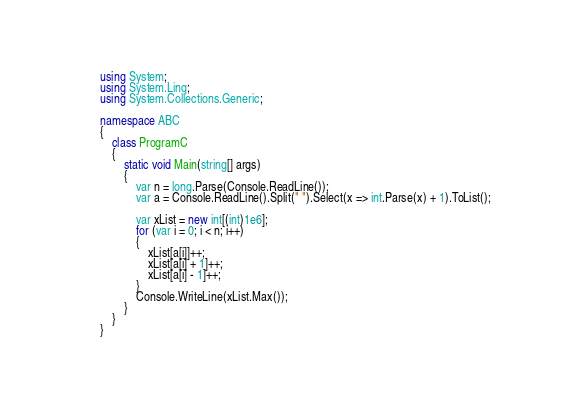Convert code to text. <code><loc_0><loc_0><loc_500><loc_500><_C#_>using System;
using System.Linq;
using System.Collections.Generic;

namespace ABC
{
    class ProgramC
    {
        static void Main(string[] args)
        {
            var n = long.Parse(Console.ReadLine());
            var a = Console.ReadLine().Split(" ").Select(x => int.Parse(x) + 1).ToList();

            var xList = new int[(int)1e6];
            for (var i = 0; i < n; i++)
            {
                xList[a[i]]++;
                xList[a[i] + 1]++;
                xList[a[i] - 1]++;
            }
            Console.WriteLine(xList.Max());
        }
    }
}
</code> 